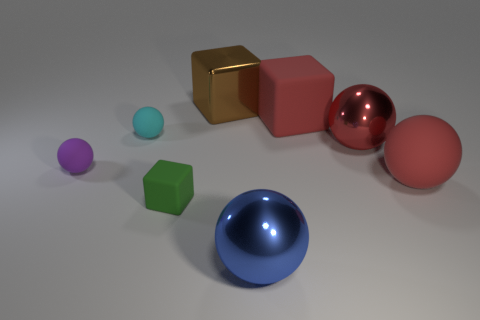What number of other objects are the same size as the red metal object?
Ensure brevity in your answer.  4. What is the green thing made of?
Keep it short and to the point. Rubber. Is the number of large brown things that are in front of the large brown metallic thing greater than the number of big red shiny cylinders?
Make the answer very short. No. Are there any tiny gray metal cubes?
Your answer should be compact. No. What number of other things are the same shape as the tiny cyan thing?
Your answer should be very brief. 4. Do the block on the right side of the large blue shiny sphere and the rubber object that is right of the large red metal ball have the same color?
Make the answer very short. Yes. What is the size of the rubber cube that is in front of the metallic thing right of the cube on the right side of the big blue sphere?
Keep it short and to the point. Small. There is a big object that is in front of the large red shiny thing and behind the big blue metallic object; what shape is it?
Keep it short and to the point. Sphere. Is the number of big metal objects that are behind the small purple matte sphere the same as the number of small matte balls behind the small green rubber cube?
Keep it short and to the point. Yes. Are there any tiny purple spheres made of the same material as the cyan object?
Your response must be concise. Yes. 